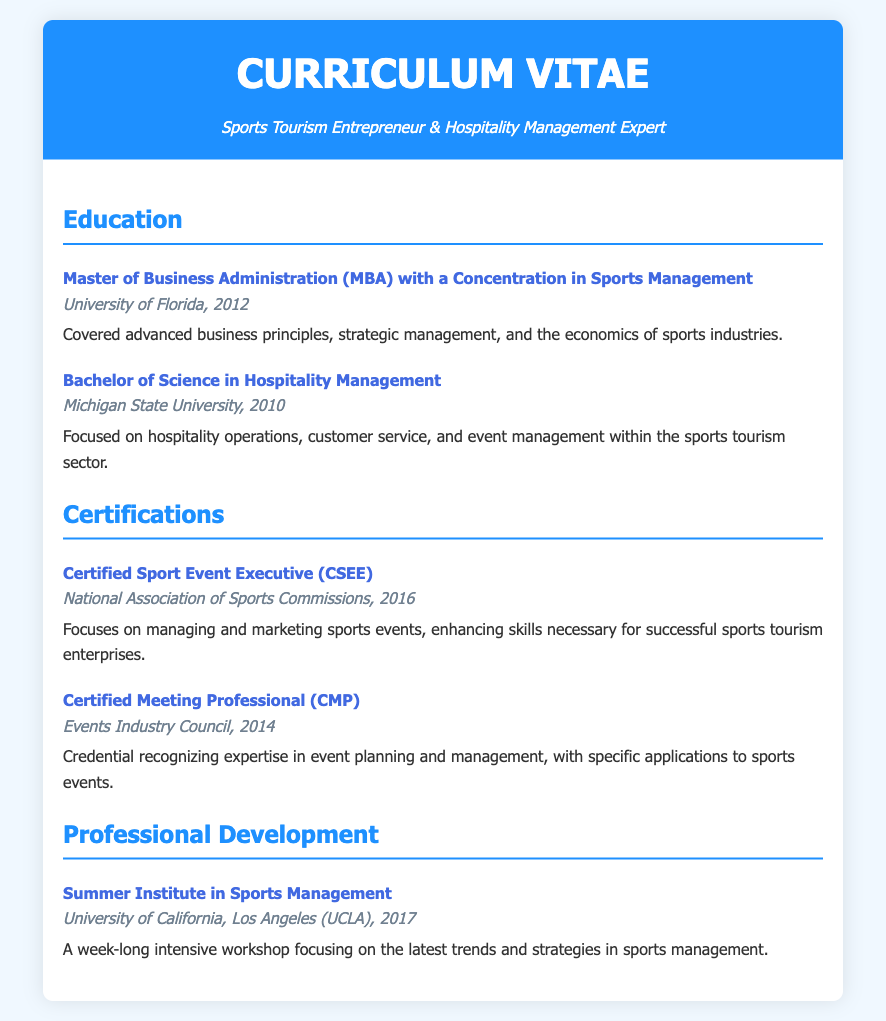What degree was obtained at the University of Florida? The degree obtained at the University of Florida is a Master of Business Administration with a concentration in Sports Management.
Answer: Master of Business Administration When did the entrepreneur graduate from Michigan State University? The entrepreneur graduated from Michigan State University in 2010.
Answer: 2010 What certification was received in 2016? The certification received in 2016 is the Certified Sport Event Executive.
Answer: Certified Sport Event Executive Which organization awarded the Certified Meeting Professional credential? The Certified Meeting Professional credential was awarded by the Events Industry Council.
Answer: Events Industry Council What was the focus of the Bachelor of Science in Hospitality Management? The focus of the Bachelor of Science in Hospitality Management was on hospitality operations, customer service, and event management within the sports tourism sector.
Answer: Hospitality operations, customer service, and event management How long was the Summer Institute in Sports Management? The Summer Institute in Sports Management was a week-long intensive workshop.
Answer: Week-long What is the title of the professional development entry? The title of the professional development entry is Summer Institute in Sports Management.
Answer: Summer Institute in Sports Management In which year was the Summer Institute in Sports Management held? The Summer Institute in Sports Management was held in 2017.
Answer: 2017 